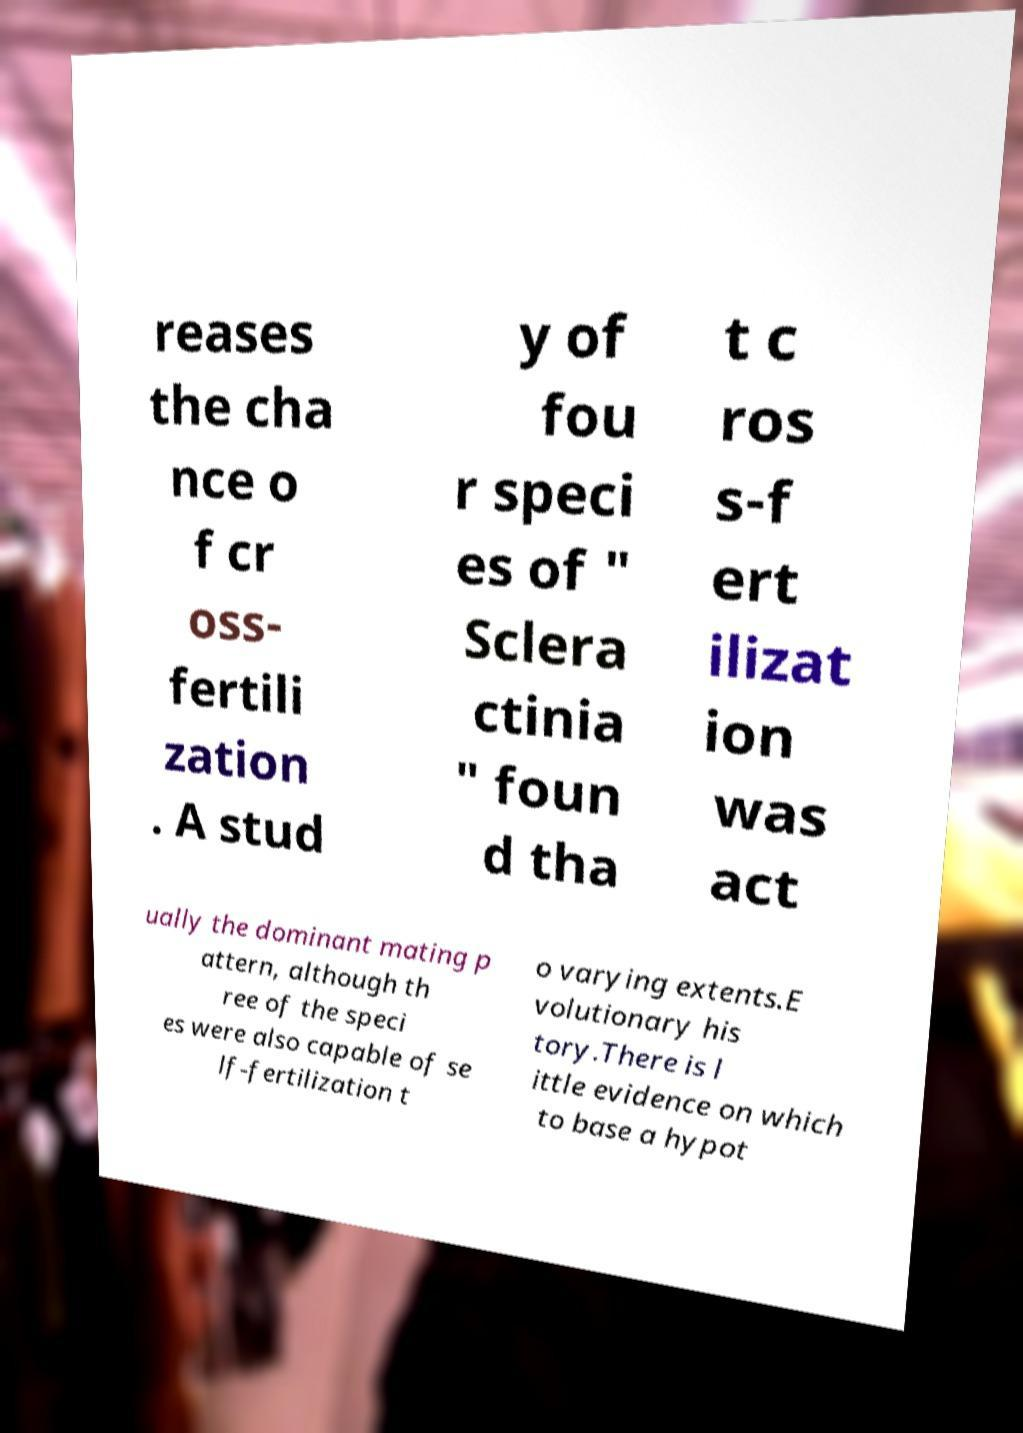I need the written content from this picture converted into text. Can you do that? reases the cha nce o f cr oss- fertili zation . A stud y of fou r speci es of " Sclera ctinia " foun d tha t c ros s-f ert ilizat ion was act ually the dominant mating p attern, although th ree of the speci es were also capable of se lf-fertilization t o varying extents.E volutionary his tory.There is l ittle evidence on which to base a hypot 